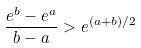<formula> <loc_0><loc_0><loc_500><loc_500>\frac { e ^ { b } - e ^ { a } } { b - a } > e ^ { ( a + b ) / 2 }</formula> 